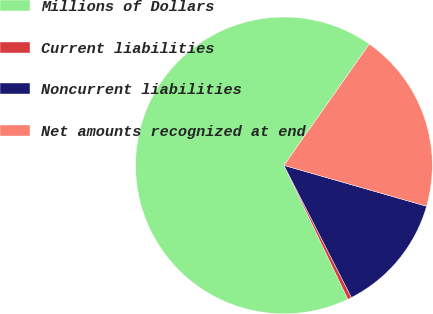Convert chart to OTSL. <chart><loc_0><loc_0><loc_500><loc_500><pie_chart><fcel>Millions of Dollars<fcel>Current liabilities<fcel>Noncurrent liabilities<fcel>Net amounts recognized at end<nl><fcel>66.84%<fcel>0.43%<fcel>13.04%<fcel>19.68%<nl></chart> 